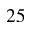Convert formula to latex. <formula><loc_0><loc_0><loc_500><loc_500>2 5</formula> 